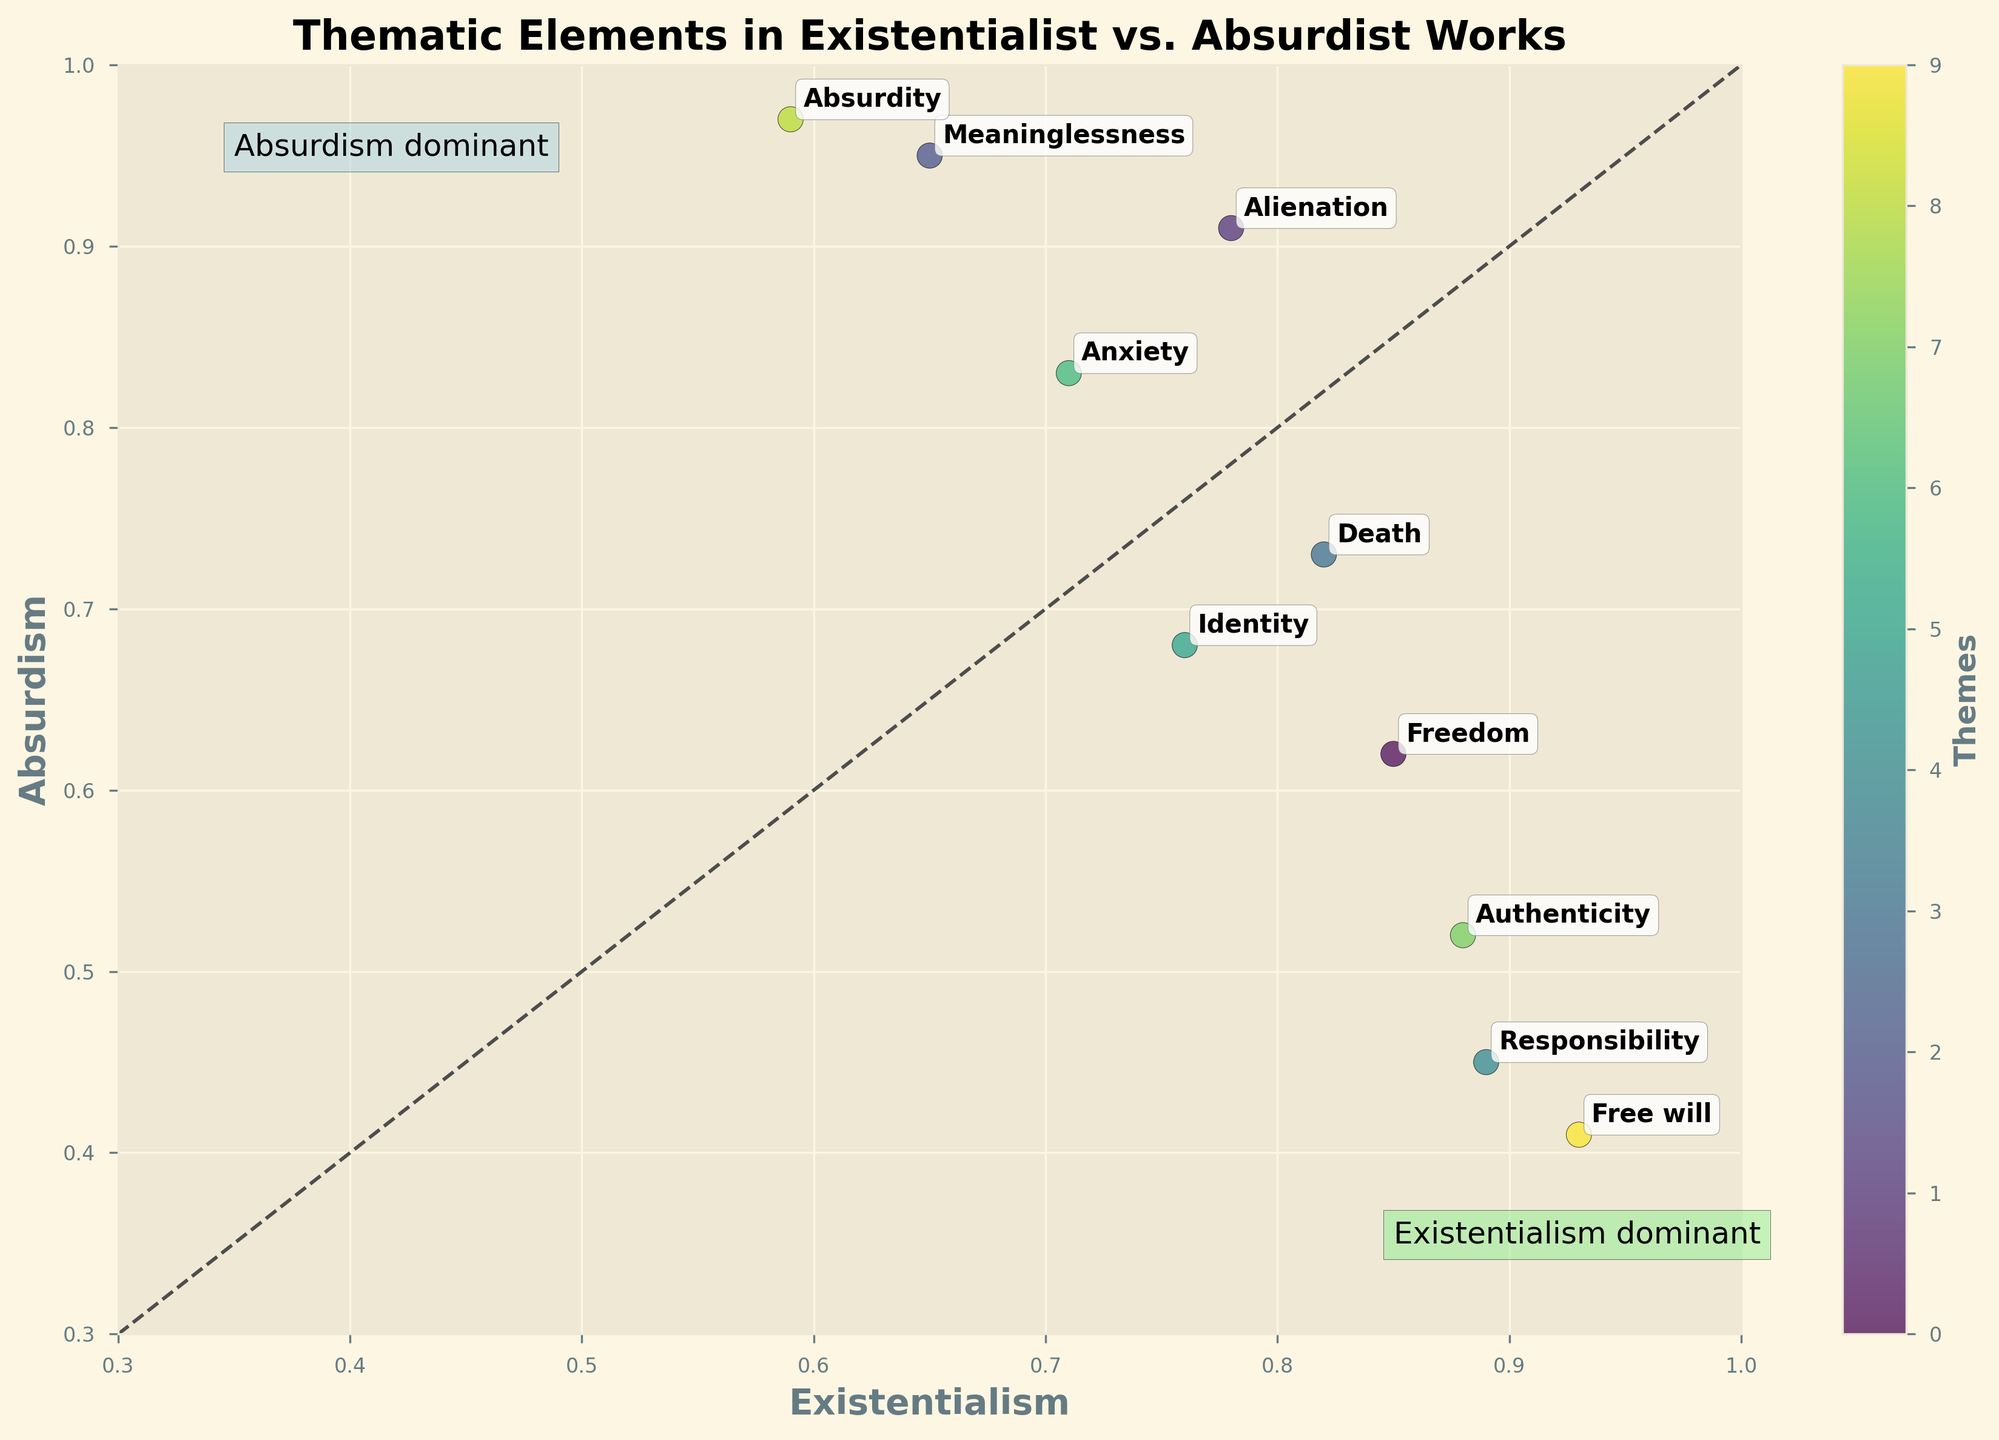What is the title of the figure? The title of the figure is displayed at the top and is labeled 'Thematic Elements in Existentialist vs. Absurdist Works'.
Answer: Thematic Elements in Existentialist vs. Absurdist Works Which theme has the highest frequency in Existentialist works? The label closest to the maximum of the existentialism axis (1.0) indicates the theme with the highest frequency. 'Free will' is closest to this value.
Answer: Free will Which theme is more dominant in Absurdist works, Absurdity or Freedom? The dot labeled 'Absurdity' is higher on the Absurdism axis than the dot labeled 'Freedom'. Therefore, 'Absurdity' is more dominant in Absurdist works.
Answer: Absurdity How many themes have a higher frequency in Absurdist works compared to Existentialist works? Count the dots that are above the diagonal dashed line, as this represents themes where absurdism's frequency exceeds existentialism's frequency. 'Alienation', 'Meaninglessness', 'Anxiety', and 'Absurdity' are above the line.
Answer: 4 Which theme shows nearly equal representation in both Existentialist and Absurdist works? Identify the dot closest to the dashed diagonal line representing equality in both themes. The theme 'Death' appears closest to this line.
Answer: Death Which thematic element has the lowest frequency in Absurdist works, and what is its value? The label closest to the minimum of the absurdism axis (0.3) indicates this theme. 'Free will' has the lowest value, which is 0.41.
Answer: Free will with 0.41 What are the two themes located near the 'Existentialism dominant' text box? Look within the vicinity of the 'Existentialism dominant' label (light green box). 'Responsibility' and 'Authenticity' are in this area.
Answer: Responsibility and Authenticity Compare the values of 'Identity' in Existentialist and Absurdist works. Which has a higher frequency and by how much? Refer to the position of the 'Identity' label on both axes. In Existentialist works, 'Identity' is 0.76, and in Absurdist works, it is 0.68. The difference is 0.76 - 0.68 = 0.08.
Answer: Existentialist by 0.08 Which themes lie within the 'Absurdism dominant' area of the plot? Look within the vicinity of the 'Absurdism dominant' label (light blue box). 'Alienation', 'Meaninglessness', and 'Absurdity' are in this area.
Answer: Alienation, Meaninglessness, Absurdity 